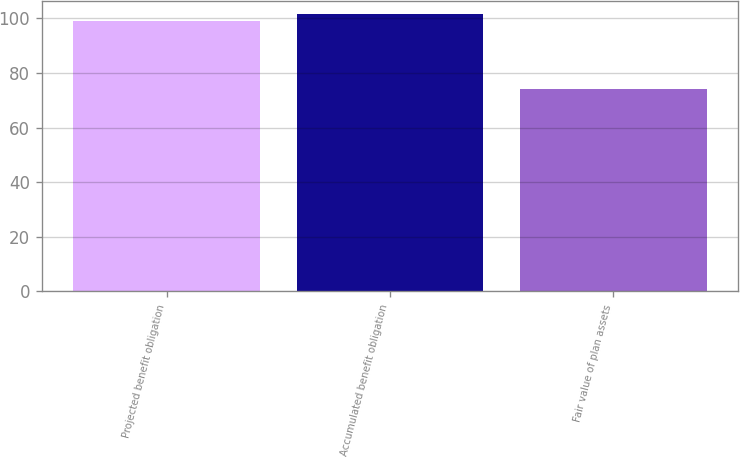Convert chart to OTSL. <chart><loc_0><loc_0><loc_500><loc_500><bar_chart><fcel>Projected benefit obligation<fcel>Accumulated benefit obligation<fcel>Fair value of plan assets<nl><fcel>99<fcel>101.5<fcel>74<nl></chart> 